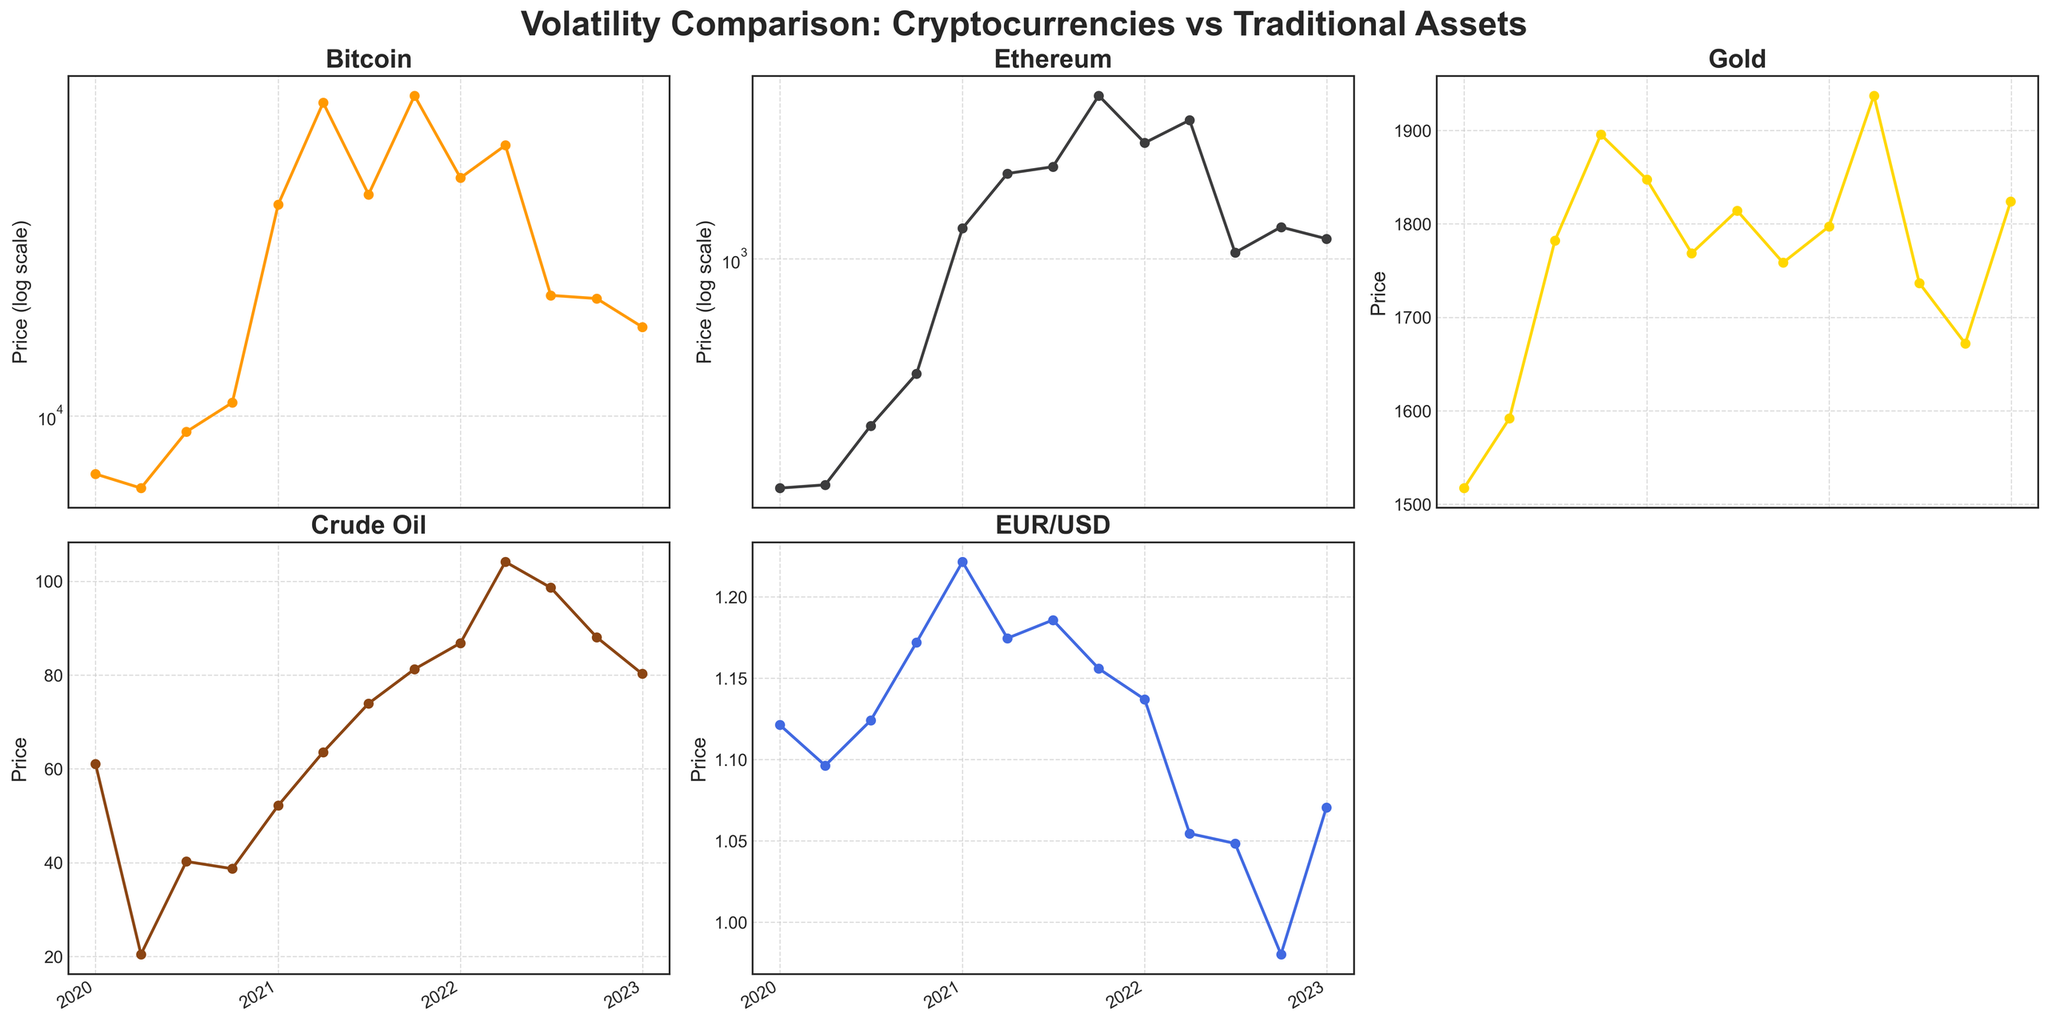What is the title of the figure? The title is usually displayed at the top of the figure. In this case, it reads 'Volatility Comparison: Cryptocurrencies vs Traditional Assets'.
Answer: Volatility Comparison: Cryptocurrencies vs Traditional Assets Which two assets are plotted using a logarithmic scale? The y-axis labels and the figure explain that the assets 'Bitcoin' and 'Ethereum' use a logarithmic scale.
Answer: Bitcoin and Ethereum How many assets have been plotted in total? By counting the individual titles of each subplot, we can see five assets are plotted: Bitcoin, Ethereum, Gold, Crude Oil, and EUR/USD.
Answer: 5 Which asset shows the most significant increase in price from January 2020 to January 2021? By looking at the line plots' steepness between these dates, Bitcoin's price rises sharply from around 7,194.89 to 33,114.36, the largest increase among the assets.
Answer: Bitcoin Between which dates does Ethereum show the biggest drop in price? Ethereum shows a significant price drop from April 2022 (~3445.42) to July 2022 (~1057.66).
Answer: April 2022 to July 2022 Which asset had the highest price at its peak, and when did this occur? The line for Bitcoin reaches its highest point (~61,318.96) around October 2021.
Answer: Bitcoin in October 2021 How does the volatility of Bitcoin compare to that of Gold over the entire period? Bitcoin's plot shows significant fluctuations (sharp rises and drops) compared to a relatively stable Gold line over the entire period.
Answer: Bitcoin is more volatile From the figure, can you identify any periods where the prices of Crude Oil and Gold showed a similar trend? From April 2020 to July 2020, both Crude Oil and Gold show an increasing trend, as seen by the upward trajectory of their respective lines.
Answer: April 2020 to July 2020 What is the approximate price of Gold at the start and end of the data period? By observing the Gold subplot, the price starts at around 1,517.27 in January 2020 and ends at around 1,824.02 in December 2022.
Answer: ~1,517.27 and ~1,824.02 Does EUR/USD show a general increasing or decreasing trend over the entire period? Observing the EUR/USD subplot, it shows an overall decreasing trend from around 1.1213 at the start to about 1.0705 at the end.
Answer: Decreasing 